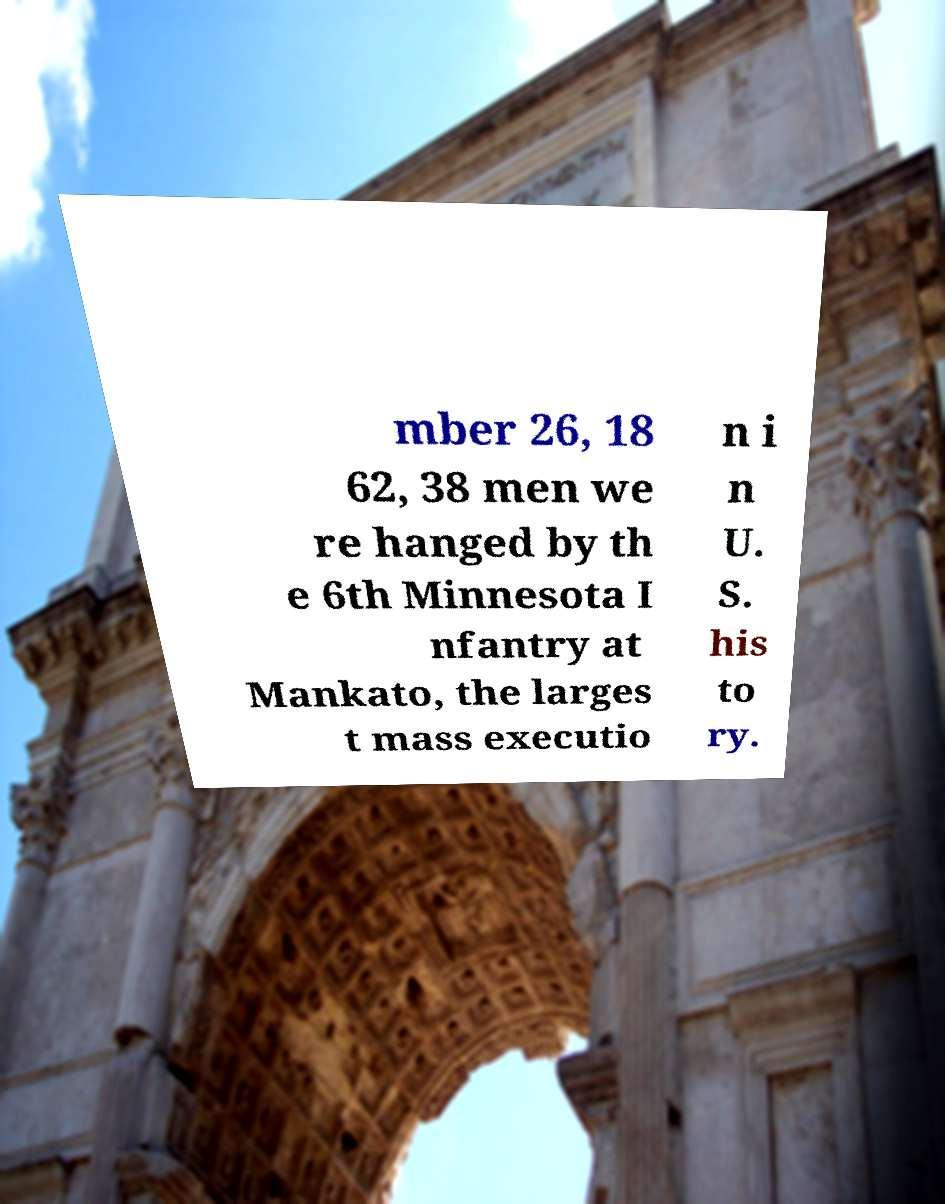Can you accurately transcribe the text from the provided image for me? mber 26, 18 62, 38 men we re hanged by th e 6th Minnesota I nfantry at Mankato, the larges t mass executio n i n U. S. his to ry. 